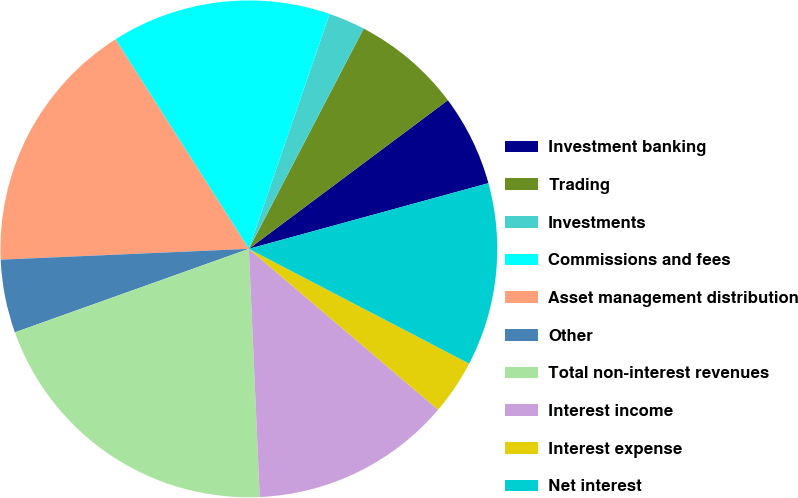Convert chart. <chart><loc_0><loc_0><loc_500><loc_500><pie_chart><fcel>Investment banking<fcel>Trading<fcel>Investments<fcel>Commissions and fees<fcel>Asset management distribution<fcel>Other<fcel>Total non-interest revenues<fcel>Interest income<fcel>Interest expense<fcel>Net interest<nl><fcel>5.95%<fcel>7.14%<fcel>2.38%<fcel>14.29%<fcel>16.67%<fcel>4.76%<fcel>20.24%<fcel>13.09%<fcel>3.57%<fcel>11.9%<nl></chart> 